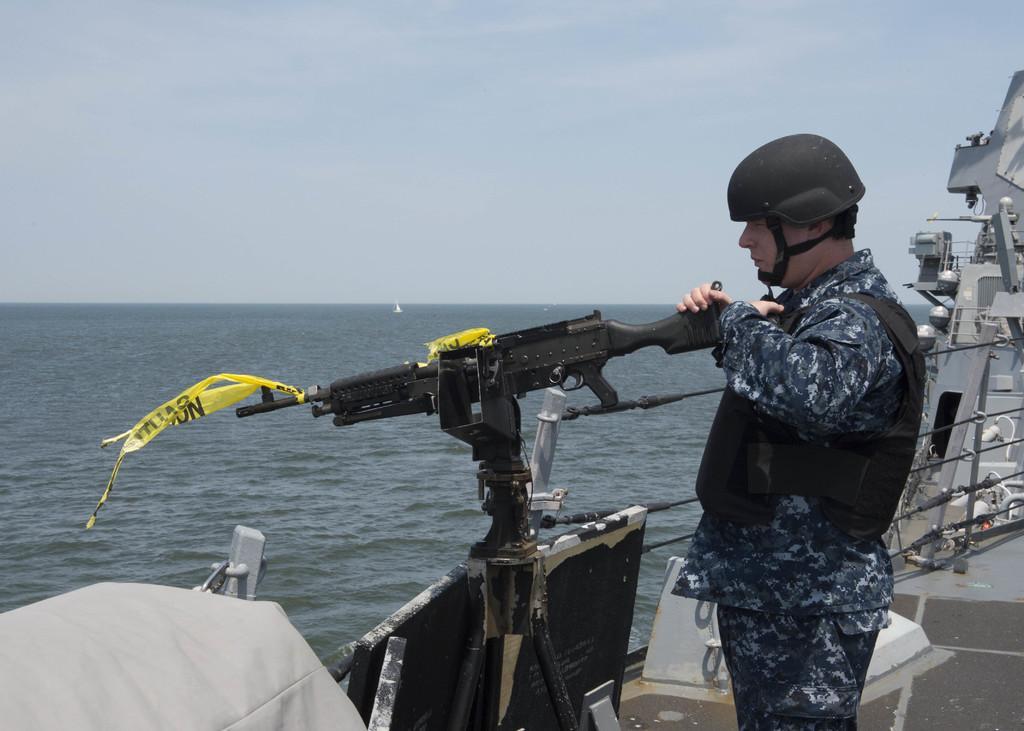Please provide a concise description of this image. This image is taken outdoors. At the top of the image there is a sky with clouds. On the right side of the image there is a ship on the sea and a man is standing on the ship and aiming a gun to shoot. In the middle of the image there is a sea. 